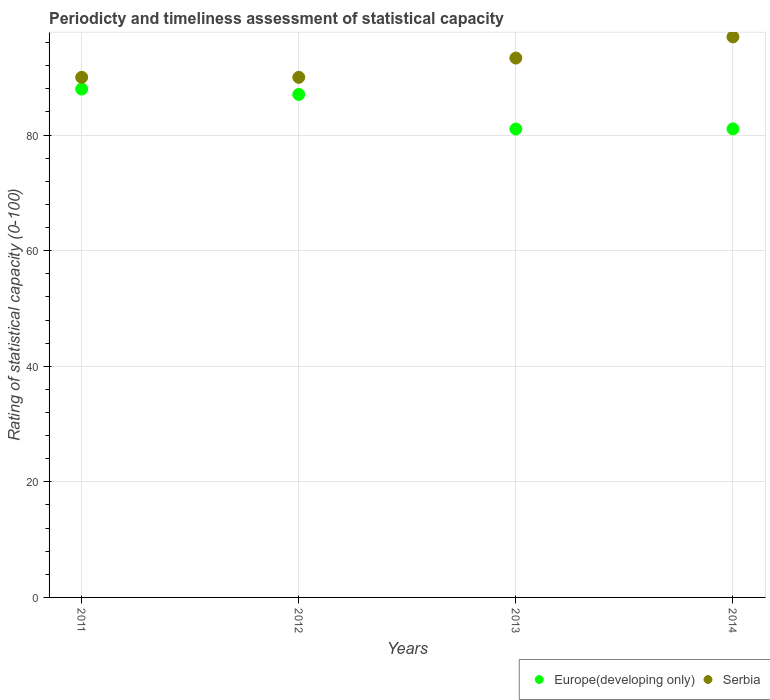What is the rating of statistical capacity in Europe(developing only) in 2012?
Provide a short and direct response. 87.04. Across all years, what is the maximum rating of statistical capacity in Serbia?
Your answer should be compact. 97. In which year was the rating of statistical capacity in Europe(developing only) maximum?
Ensure brevity in your answer.  2011. What is the total rating of statistical capacity in Europe(developing only) in the graph?
Offer a terse response. 337.12. What is the difference between the rating of statistical capacity in Serbia in 2013 and that in 2014?
Make the answer very short. -3.67. What is the difference between the rating of statistical capacity in Serbia in 2011 and the rating of statistical capacity in Europe(developing only) in 2013?
Provide a short and direct response. 8.95. What is the average rating of statistical capacity in Europe(developing only) per year?
Provide a short and direct response. 84.28. In the year 2012, what is the difference between the rating of statistical capacity in Europe(developing only) and rating of statistical capacity in Serbia?
Give a very brief answer. -2.96. What is the ratio of the rating of statistical capacity in Serbia in 2012 to that in 2014?
Give a very brief answer. 0.93. Is the rating of statistical capacity in Europe(developing only) in 2011 less than that in 2014?
Your answer should be compact. No. What is the difference between the highest and the second highest rating of statistical capacity in Europe(developing only)?
Give a very brief answer. 0.93. What is the difference between the highest and the lowest rating of statistical capacity in Europe(developing only)?
Provide a short and direct response. 6.91. In how many years, is the rating of statistical capacity in Serbia greater than the average rating of statistical capacity in Serbia taken over all years?
Offer a very short reply. 2. Is the sum of the rating of statistical capacity in Serbia in 2011 and 2013 greater than the maximum rating of statistical capacity in Europe(developing only) across all years?
Ensure brevity in your answer.  Yes. How many dotlines are there?
Your answer should be compact. 2. How many years are there in the graph?
Your answer should be very brief. 4. What is the difference between two consecutive major ticks on the Y-axis?
Your answer should be compact. 20. Does the graph contain any zero values?
Ensure brevity in your answer.  No. Does the graph contain grids?
Give a very brief answer. Yes. How many legend labels are there?
Offer a terse response. 2. What is the title of the graph?
Provide a succinct answer. Periodicty and timeliness assessment of statistical capacity. What is the label or title of the Y-axis?
Offer a terse response. Rating of statistical capacity (0-100). What is the Rating of statistical capacity (0-100) in Europe(developing only) in 2011?
Provide a succinct answer. 87.96. What is the Rating of statistical capacity (0-100) of Serbia in 2011?
Offer a terse response. 90. What is the Rating of statistical capacity (0-100) in Europe(developing only) in 2012?
Make the answer very short. 87.04. What is the Rating of statistical capacity (0-100) in Europe(developing only) in 2013?
Provide a short and direct response. 81.05. What is the Rating of statistical capacity (0-100) in Serbia in 2013?
Offer a terse response. 93.33. What is the Rating of statistical capacity (0-100) of Europe(developing only) in 2014?
Your response must be concise. 81.07. What is the Rating of statistical capacity (0-100) in Serbia in 2014?
Your response must be concise. 97. Across all years, what is the maximum Rating of statistical capacity (0-100) in Europe(developing only)?
Provide a succinct answer. 87.96. Across all years, what is the maximum Rating of statistical capacity (0-100) of Serbia?
Provide a succinct answer. 97. Across all years, what is the minimum Rating of statistical capacity (0-100) of Europe(developing only)?
Your response must be concise. 81.05. What is the total Rating of statistical capacity (0-100) of Europe(developing only) in the graph?
Make the answer very short. 337.12. What is the total Rating of statistical capacity (0-100) in Serbia in the graph?
Keep it short and to the point. 370.33. What is the difference between the Rating of statistical capacity (0-100) of Europe(developing only) in 2011 and that in 2012?
Offer a very short reply. 0.93. What is the difference between the Rating of statistical capacity (0-100) in Serbia in 2011 and that in 2012?
Your response must be concise. 0. What is the difference between the Rating of statistical capacity (0-100) of Europe(developing only) in 2011 and that in 2013?
Keep it short and to the point. 6.91. What is the difference between the Rating of statistical capacity (0-100) in Serbia in 2011 and that in 2013?
Ensure brevity in your answer.  -3.33. What is the difference between the Rating of statistical capacity (0-100) in Europe(developing only) in 2011 and that in 2014?
Your answer should be compact. 6.89. What is the difference between the Rating of statistical capacity (0-100) in Serbia in 2011 and that in 2014?
Your answer should be compact. -7. What is the difference between the Rating of statistical capacity (0-100) in Europe(developing only) in 2012 and that in 2013?
Your response must be concise. 5.98. What is the difference between the Rating of statistical capacity (0-100) in Serbia in 2012 and that in 2013?
Keep it short and to the point. -3.33. What is the difference between the Rating of statistical capacity (0-100) of Europe(developing only) in 2012 and that in 2014?
Provide a succinct answer. 5.97. What is the difference between the Rating of statistical capacity (0-100) of Serbia in 2012 and that in 2014?
Give a very brief answer. -7. What is the difference between the Rating of statistical capacity (0-100) in Europe(developing only) in 2013 and that in 2014?
Your answer should be very brief. -0.02. What is the difference between the Rating of statistical capacity (0-100) of Serbia in 2013 and that in 2014?
Provide a succinct answer. -3.67. What is the difference between the Rating of statistical capacity (0-100) in Europe(developing only) in 2011 and the Rating of statistical capacity (0-100) in Serbia in 2012?
Keep it short and to the point. -2.04. What is the difference between the Rating of statistical capacity (0-100) in Europe(developing only) in 2011 and the Rating of statistical capacity (0-100) in Serbia in 2013?
Keep it short and to the point. -5.37. What is the difference between the Rating of statistical capacity (0-100) of Europe(developing only) in 2011 and the Rating of statistical capacity (0-100) of Serbia in 2014?
Make the answer very short. -9.04. What is the difference between the Rating of statistical capacity (0-100) of Europe(developing only) in 2012 and the Rating of statistical capacity (0-100) of Serbia in 2013?
Provide a succinct answer. -6.3. What is the difference between the Rating of statistical capacity (0-100) in Europe(developing only) in 2012 and the Rating of statistical capacity (0-100) in Serbia in 2014?
Offer a terse response. -9.96. What is the difference between the Rating of statistical capacity (0-100) of Europe(developing only) in 2013 and the Rating of statistical capacity (0-100) of Serbia in 2014?
Keep it short and to the point. -15.95. What is the average Rating of statistical capacity (0-100) of Europe(developing only) per year?
Provide a succinct answer. 84.28. What is the average Rating of statistical capacity (0-100) of Serbia per year?
Provide a succinct answer. 92.58. In the year 2011, what is the difference between the Rating of statistical capacity (0-100) in Europe(developing only) and Rating of statistical capacity (0-100) in Serbia?
Ensure brevity in your answer.  -2.04. In the year 2012, what is the difference between the Rating of statistical capacity (0-100) in Europe(developing only) and Rating of statistical capacity (0-100) in Serbia?
Make the answer very short. -2.96. In the year 2013, what is the difference between the Rating of statistical capacity (0-100) of Europe(developing only) and Rating of statistical capacity (0-100) of Serbia?
Offer a terse response. -12.28. In the year 2014, what is the difference between the Rating of statistical capacity (0-100) in Europe(developing only) and Rating of statistical capacity (0-100) in Serbia?
Offer a very short reply. -15.93. What is the ratio of the Rating of statistical capacity (0-100) in Europe(developing only) in 2011 to that in 2012?
Your response must be concise. 1.01. What is the ratio of the Rating of statistical capacity (0-100) of Serbia in 2011 to that in 2012?
Ensure brevity in your answer.  1. What is the ratio of the Rating of statistical capacity (0-100) of Europe(developing only) in 2011 to that in 2013?
Offer a terse response. 1.09. What is the ratio of the Rating of statistical capacity (0-100) of Serbia in 2011 to that in 2013?
Your response must be concise. 0.96. What is the ratio of the Rating of statistical capacity (0-100) in Europe(developing only) in 2011 to that in 2014?
Make the answer very short. 1.08. What is the ratio of the Rating of statistical capacity (0-100) in Serbia in 2011 to that in 2014?
Make the answer very short. 0.93. What is the ratio of the Rating of statistical capacity (0-100) of Europe(developing only) in 2012 to that in 2013?
Offer a very short reply. 1.07. What is the ratio of the Rating of statistical capacity (0-100) of Europe(developing only) in 2012 to that in 2014?
Your answer should be compact. 1.07. What is the ratio of the Rating of statistical capacity (0-100) of Serbia in 2012 to that in 2014?
Your answer should be very brief. 0.93. What is the ratio of the Rating of statistical capacity (0-100) of Europe(developing only) in 2013 to that in 2014?
Your answer should be compact. 1. What is the ratio of the Rating of statistical capacity (0-100) of Serbia in 2013 to that in 2014?
Ensure brevity in your answer.  0.96. What is the difference between the highest and the second highest Rating of statistical capacity (0-100) in Europe(developing only)?
Give a very brief answer. 0.93. What is the difference between the highest and the second highest Rating of statistical capacity (0-100) in Serbia?
Ensure brevity in your answer.  3.67. What is the difference between the highest and the lowest Rating of statistical capacity (0-100) in Europe(developing only)?
Keep it short and to the point. 6.91. 